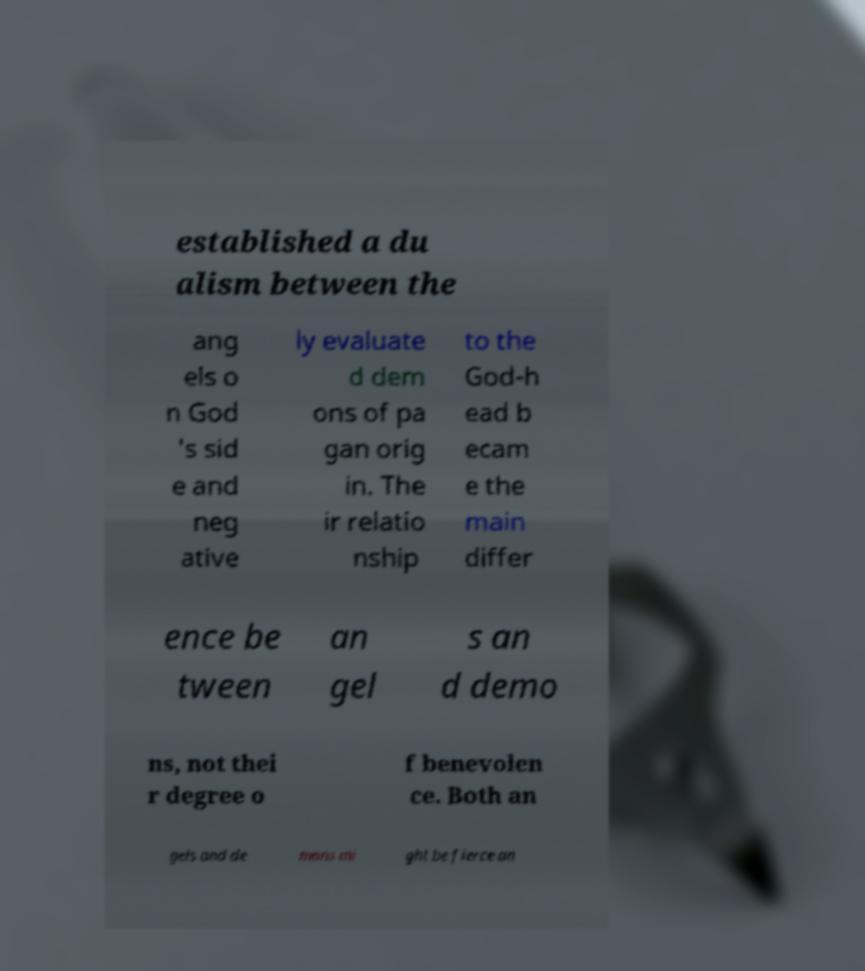Could you assist in decoding the text presented in this image and type it out clearly? established a du alism between the ang els o n God 's sid e and neg ative ly evaluate d dem ons of pa gan orig in. The ir relatio nship to the God-h ead b ecam e the main differ ence be tween an gel s an d demo ns, not thei r degree o f benevolen ce. Both an gels and de mons mi ght be fierce an 